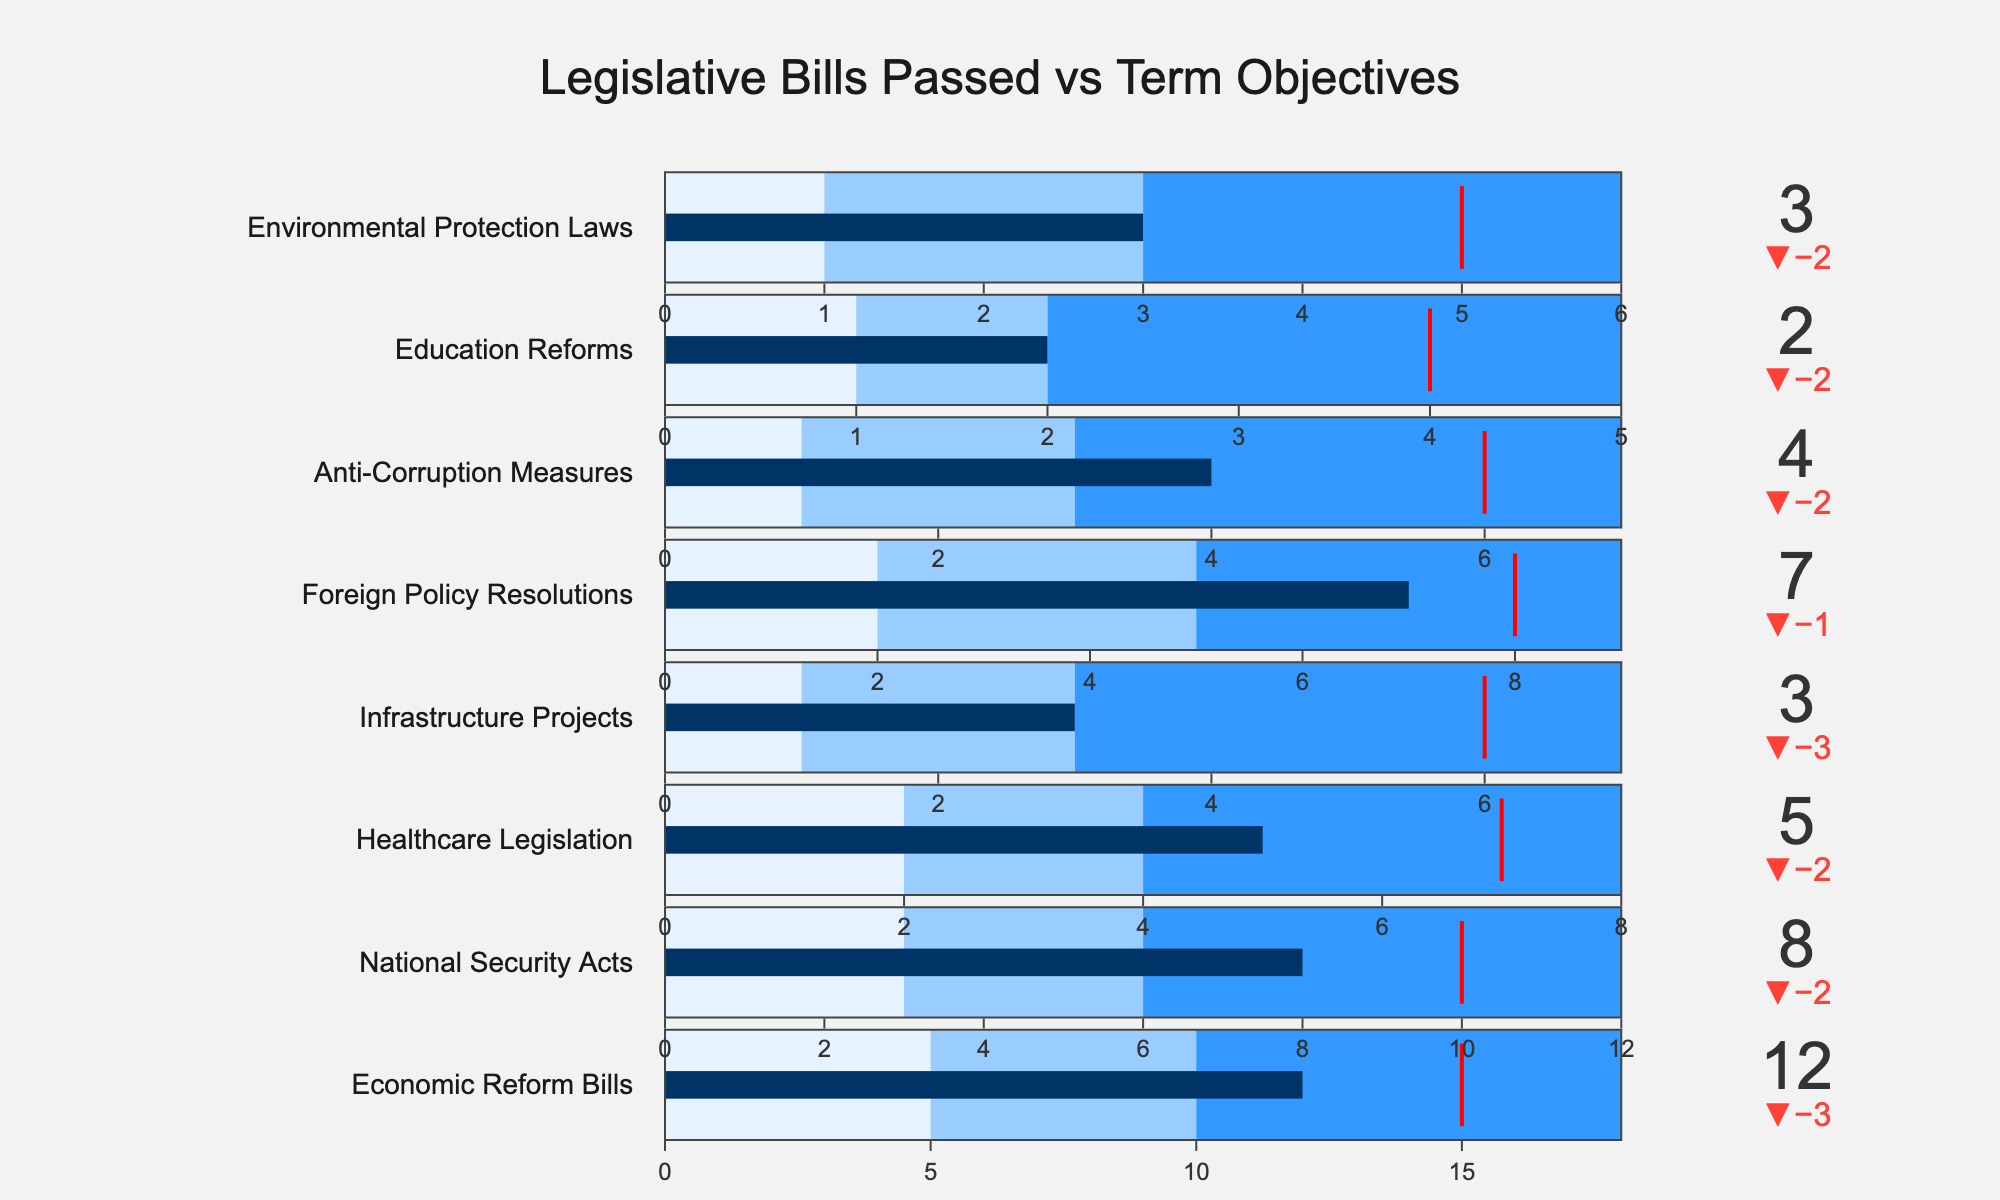What's the title of this figure? The title is displayed prominently at the top of the figure.
Answer: Legislative Bills Passed vs Term Objectives How many legislative categories are shown in the bullet chart? By counting the number of unique rows (titles) in the chart, we can determine the number of categories.
Answer: 8 Which legislative category has the actual value closest to its target? Compare the "Actual" and "Target" values for each category and see which pair has the smallest difference.
Answer: Foreign Policy Resolutions Which legislative category has the largest difference between the actual value and the target? By examining the difference between "Actual" and "Target" for each category, find the category with the maximum difference.
Answer: Healthcare Legislation What's the color indicating the highest performance range in the bullet chart? The color representing the highest range can be seen in the third section of each gauge.
Answer: Dark Blue Which legislative category has the actual value furthest from its target? Identify the category with the greatest absolute difference between the "Actual" and "Target" values.
Answer: Education Reforms What is the target number of Healthcare Legislation bills? Locate the "Healthcare Legislation" row and identify the target value.
Answer: 7 Which legislative category performed the best compared to its target? Find the one with the smallest negative or positive delta, indicating actual performance close to or exceeding the target.
Answer: Foreign Policy Resolutions What is the range of bills for "National Security Acts"? Identify the minimum and maximum values in the gauge axis range for this category.
Answer: 0 to 12 Which legislative category has the poorest actual value relative to the desired range? Compare actual values to their respective desired range across all categories, looking for the largest discrepancy below the target.
Answer: Education Reforms 